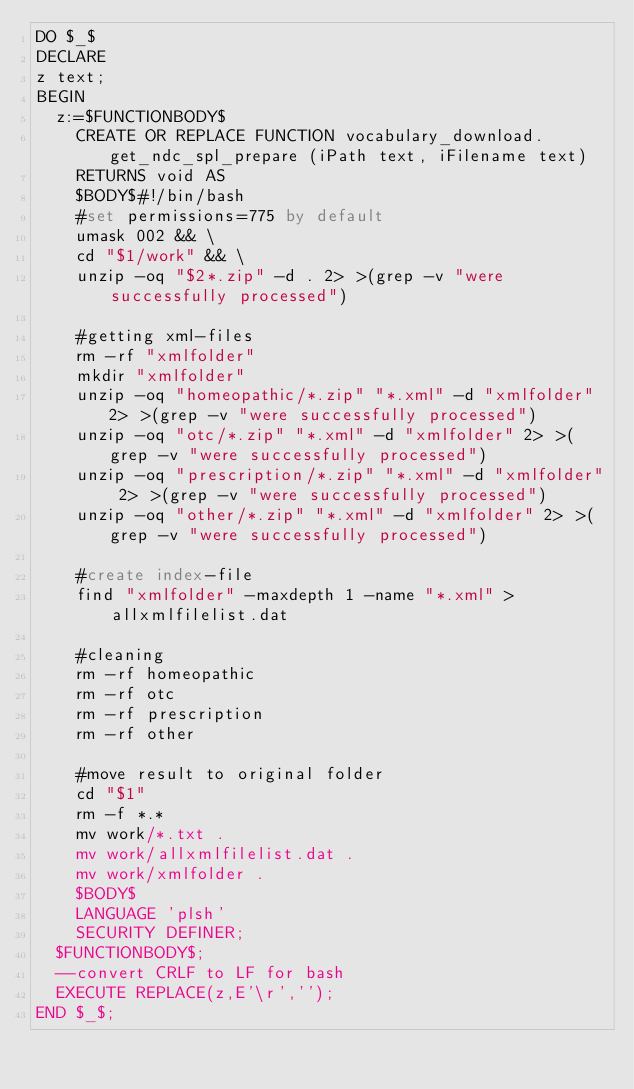Convert code to text. <code><loc_0><loc_0><loc_500><loc_500><_SQL_>DO $_$
DECLARE
z text;
BEGIN
  z:=$FUNCTIONBODY$
    CREATE OR REPLACE FUNCTION vocabulary_download.get_ndc_spl_prepare (iPath text, iFilename text)
    RETURNS void AS
    $BODY$#!/bin/bash
    #set permissions=775 by default
    umask 002 && \
    cd "$1/work" && \
    unzip -oq "$2*.zip" -d . 2> >(grep -v "were successfully processed")
    
    #getting xml-files
    rm -rf "xmlfolder"
    mkdir "xmlfolder"
    unzip -oq "homeopathic/*.zip" "*.xml" -d "xmlfolder" 2> >(grep -v "were successfully processed")
    unzip -oq "otc/*.zip" "*.xml" -d "xmlfolder" 2> >(grep -v "were successfully processed")
    unzip -oq "prescription/*.zip" "*.xml" -d "xmlfolder" 2> >(grep -v "were successfully processed")
    unzip -oq "other/*.zip" "*.xml" -d "xmlfolder" 2> >(grep -v "were successfully processed")
    
    #create index-file
    find "xmlfolder" -maxdepth 1 -name "*.xml" > allxmlfilelist.dat
    
    #cleaning
    rm -rf homeopathic
    rm -rf otc
    rm -rf prescription
    rm -rf other
    
    #move result to original folder
    cd "$1"
    rm -f *.*
    mv work/*.txt .
    mv work/allxmlfilelist.dat .
    mv work/xmlfolder .
    $BODY$
    LANGUAGE 'plsh'
    SECURITY DEFINER;
  $FUNCTIONBODY$;
  --convert CRLF to LF for bash
  EXECUTE REPLACE(z,E'\r','');
END $_$;</code> 